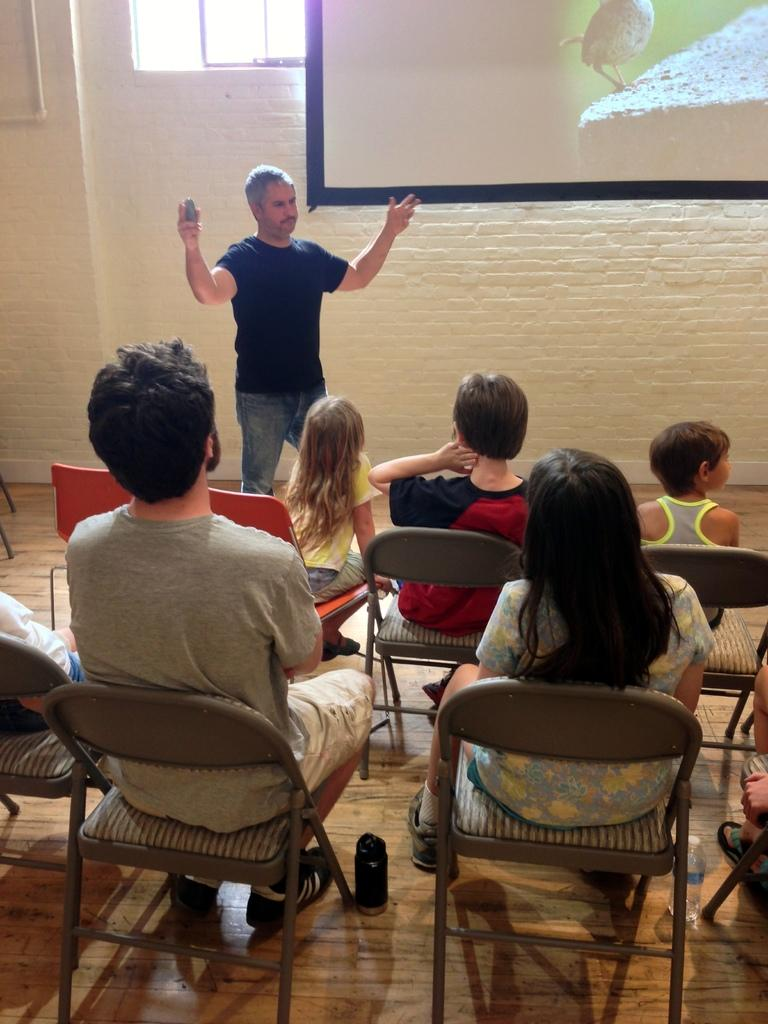Where is the setting of the image? The image is inside a room. What is the man in the image doing? There is no specific action mentioned for the man, but he is standing in the room. How many people are sitting in the room? There are persons sitting on chairs in the room. What is located on the top of the room? There is a screen on the top of the room. What color is the wall in the room? The wall is in white color. Are there any sources of natural light in the room? Yes, there are windows in the room. What type of oatmeal is being prepared by the man in the image? There is no mention of oatmeal or any food preparation in the image. The man is simply standing in the room. 